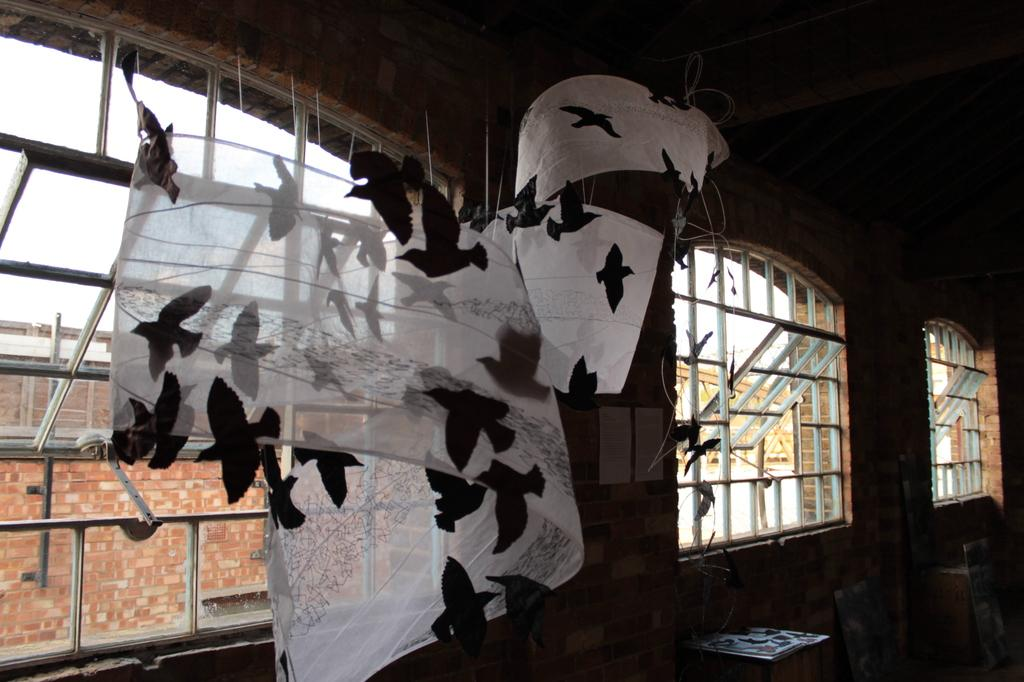What is happening in the image involving animals? There are birds flying in the image. What can be seen inside the room depicted in the image? There are clothes visible in the image. What type of windows are present in the room? There are glass windows in the room depicted in the image. What can be seen outside the room? There are buildings visible outside the room. What type of soup is being served in the image? There is no soup present in the image. How many cattle can be seen grazing in the image? There are no cattle present in the image. 